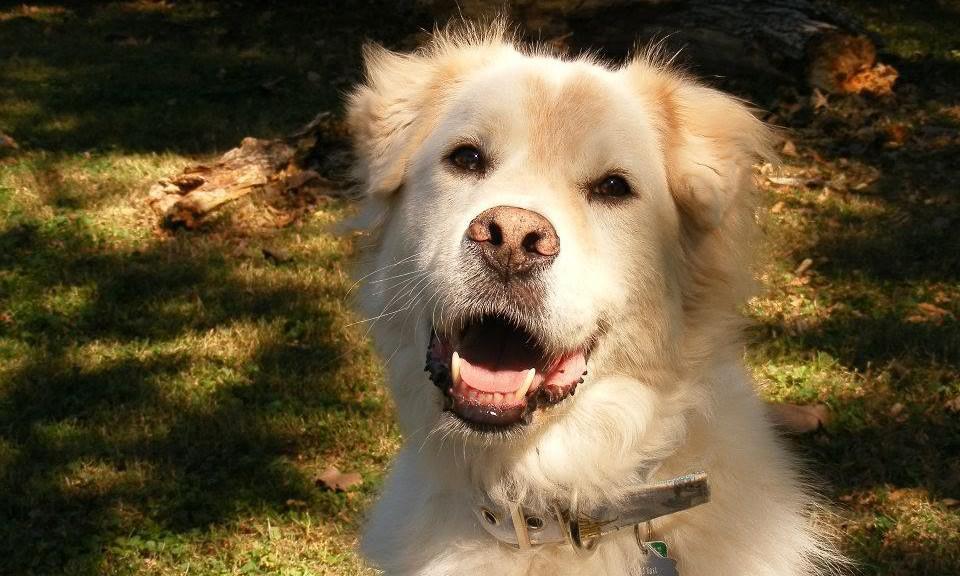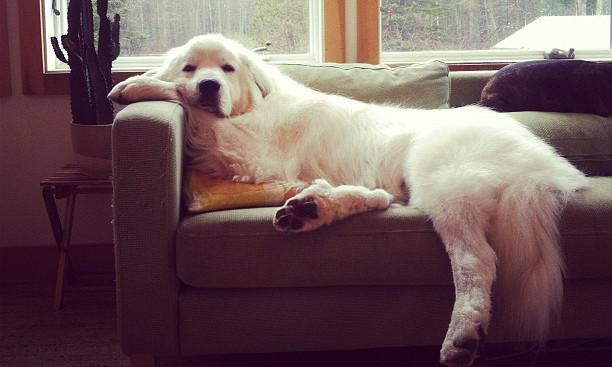The first image is the image on the left, the second image is the image on the right. Assess this claim about the two images: "An image shows a white dog draped across seating furniture.". Correct or not? Answer yes or no. Yes. The first image is the image on the left, the second image is the image on the right. Considering the images on both sides, is "In one image, a large white dog is lounging on a sofa, with its tail hanging over the front." valid? Answer yes or no. Yes. 